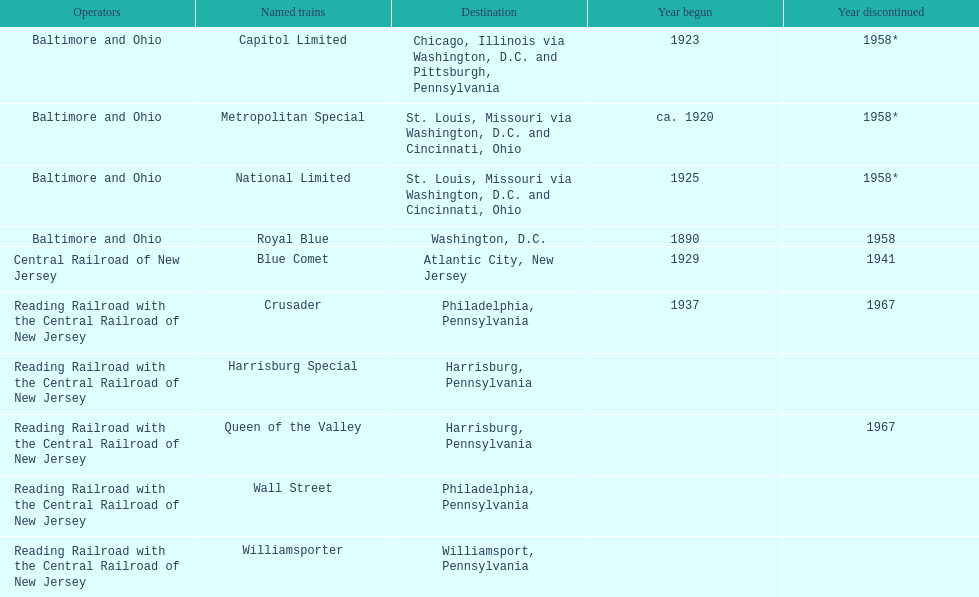Parse the full table. {'header': ['Operators', 'Named trains', 'Destination', 'Year begun', 'Year discontinued'], 'rows': [['Baltimore and Ohio', 'Capitol Limited', 'Chicago, Illinois via Washington, D.C. and Pittsburgh, Pennsylvania', '1923', '1958*'], ['Baltimore and Ohio', 'Metropolitan Special', 'St. Louis, Missouri via Washington, D.C. and Cincinnati, Ohio', 'ca. 1920', '1958*'], ['Baltimore and Ohio', 'National Limited', 'St. Louis, Missouri via Washington, D.C. and Cincinnati, Ohio', '1925', '1958*'], ['Baltimore and Ohio', 'Royal Blue', 'Washington, D.C.', '1890', '1958'], ['Central Railroad of New Jersey', 'Blue Comet', 'Atlantic City, New Jersey', '1929', '1941'], ['Reading Railroad with the Central Railroad of New Jersey', 'Crusader', 'Philadelphia, Pennsylvania', '1937', '1967'], ['Reading Railroad with the Central Railroad of New Jersey', 'Harrisburg Special', 'Harrisburg, Pennsylvania', '', ''], ['Reading Railroad with the Central Railroad of New Jersey', 'Queen of the Valley', 'Harrisburg, Pennsylvania', '', '1967'], ['Reading Railroad with the Central Railroad of New Jersey', 'Wall Street', 'Philadelphia, Pennsylvania', '', ''], ['Reading Railroad with the Central Railroad of New Jersey', 'Williamsporter', 'Williamsport, Pennsylvania', '', '']]} Which train was the earliest to start service? Royal Blue. 